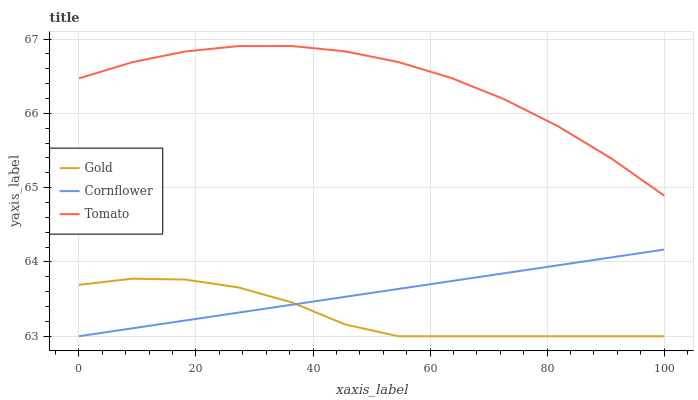Does Gold have the minimum area under the curve?
Answer yes or no. Yes. Does Tomato have the maximum area under the curve?
Answer yes or no. Yes. Does Cornflower have the minimum area under the curve?
Answer yes or no. No. Does Cornflower have the maximum area under the curve?
Answer yes or no. No. Is Cornflower the smoothest?
Answer yes or no. Yes. Is Tomato the roughest?
Answer yes or no. Yes. Is Gold the smoothest?
Answer yes or no. No. Is Gold the roughest?
Answer yes or no. No. Does Cornflower have the lowest value?
Answer yes or no. Yes. Does Tomato have the highest value?
Answer yes or no. Yes. Does Cornflower have the highest value?
Answer yes or no. No. Is Cornflower less than Tomato?
Answer yes or no. Yes. Is Tomato greater than Cornflower?
Answer yes or no. Yes. Does Gold intersect Cornflower?
Answer yes or no. Yes. Is Gold less than Cornflower?
Answer yes or no. No. Is Gold greater than Cornflower?
Answer yes or no. No. Does Cornflower intersect Tomato?
Answer yes or no. No. 